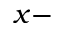Convert formula to latex. <formula><loc_0><loc_0><loc_500><loc_500>x -</formula> 